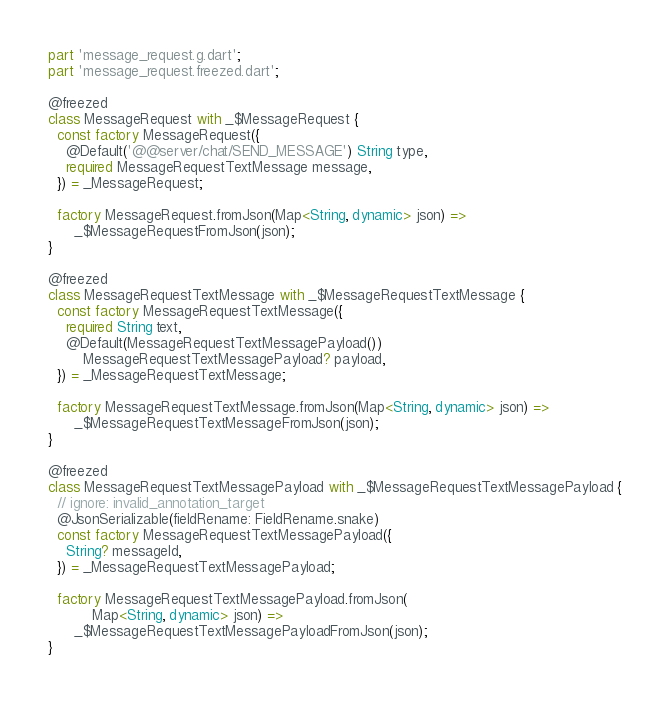Convert code to text. <code><loc_0><loc_0><loc_500><loc_500><_Dart_>
part 'message_request.g.dart';
part 'message_request.freezed.dart';

@freezed
class MessageRequest with _$MessageRequest {
  const factory MessageRequest({
    @Default('@@server/chat/SEND_MESSAGE') String type,
    required MessageRequestTextMessage message,
  }) = _MessageRequest;

  factory MessageRequest.fromJson(Map<String, dynamic> json) =>
      _$MessageRequestFromJson(json);
}

@freezed
class MessageRequestTextMessage with _$MessageRequestTextMessage {
  const factory MessageRequestTextMessage({
    required String text,
    @Default(MessageRequestTextMessagePayload())
        MessageRequestTextMessagePayload? payload,
  }) = _MessageRequestTextMessage;

  factory MessageRequestTextMessage.fromJson(Map<String, dynamic> json) =>
      _$MessageRequestTextMessageFromJson(json);
}

@freezed
class MessageRequestTextMessagePayload with _$MessageRequestTextMessagePayload {
  // ignore: invalid_annotation_target
  @JsonSerializable(fieldRename: FieldRename.snake)
  const factory MessageRequestTextMessagePayload({
    String? messageId,
  }) = _MessageRequestTextMessagePayload;

  factory MessageRequestTextMessagePayload.fromJson(
          Map<String, dynamic> json) =>
      _$MessageRequestTextMessagePayloadFromJson(json);
}
</code> 